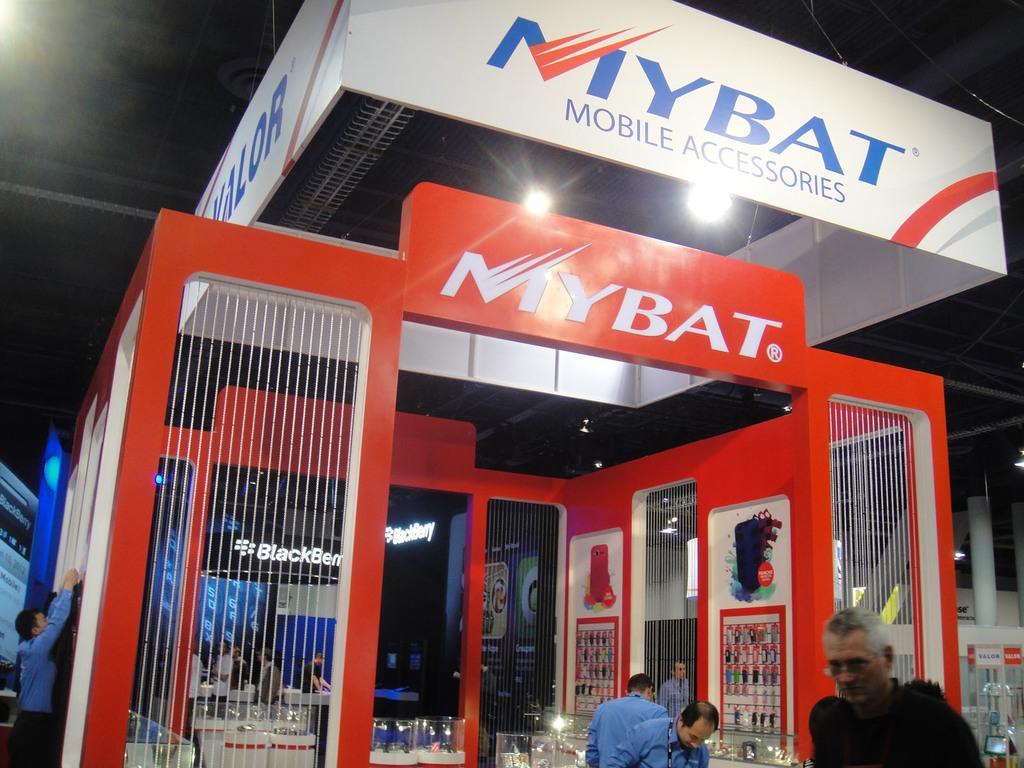Could you give a brief overview of what you see in this image? In this picture there are people and we can see store, hoardings and lights. In the background of the image we can see pillars, board and lights. 